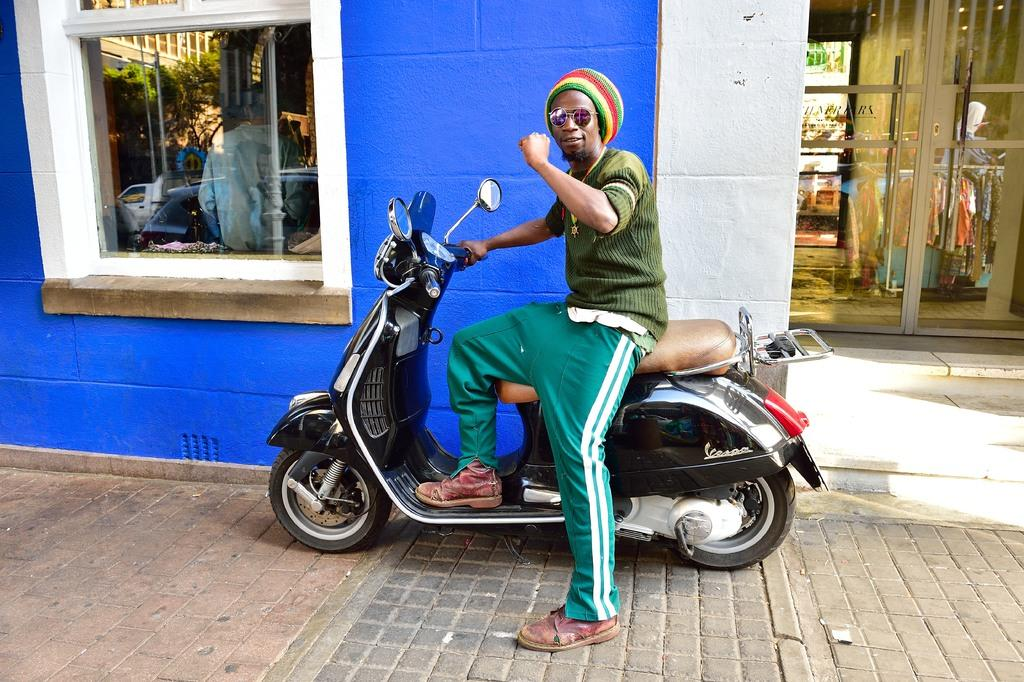What is the person in the image doing? The person is sitting on a scooter. What can be seen behind the person? There is a blue wall behind the person. Are there any openings visible in the image? Yes, there is a window visible. Is there any entrance or exit in the image? Yes, there is a door in the image. What type of stone is the person holding in their hand in the image? There is no stone present in the image; the person is sitting on a scooter. What kind of berry can be seen growing on the blue wall in the image? There are no berries present on the blue wall in the image. 